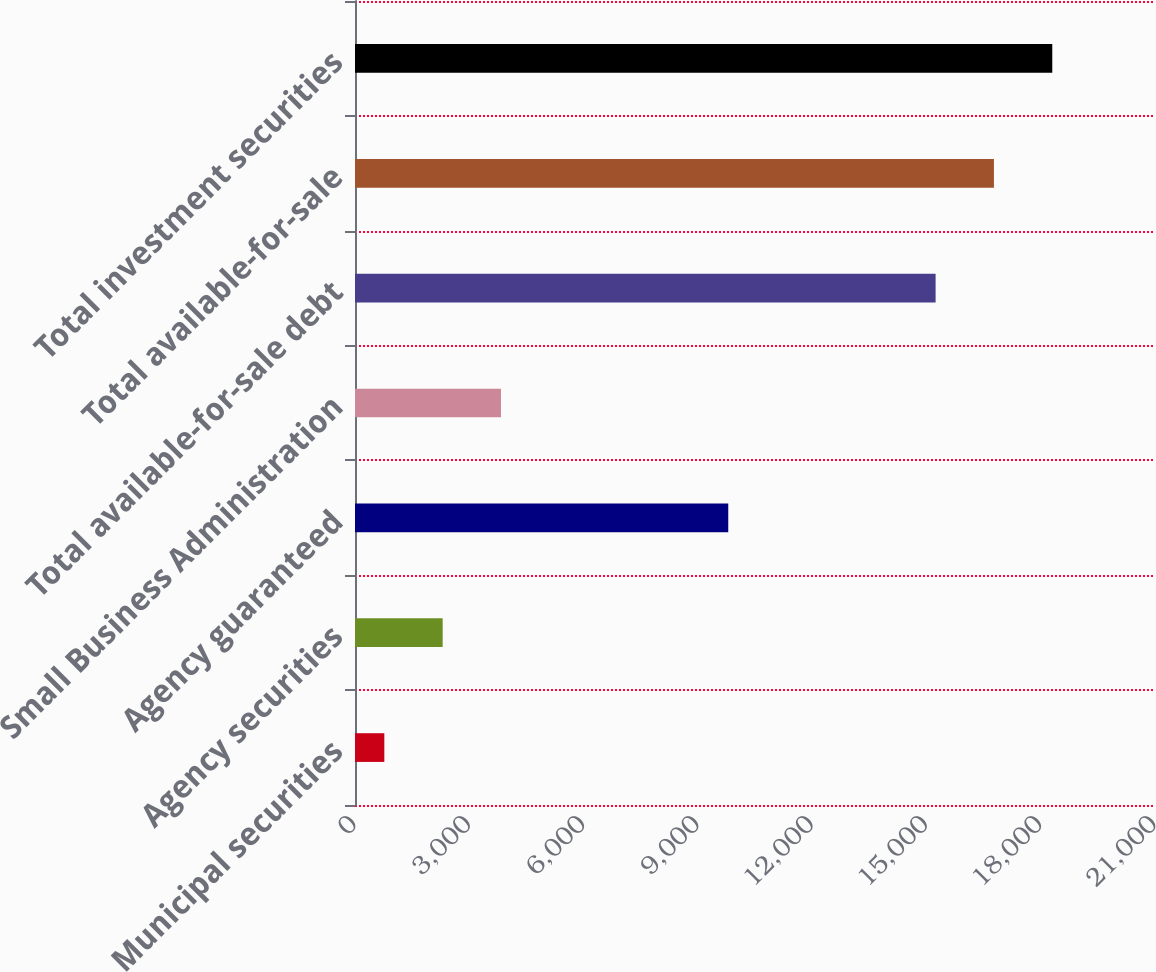Convert chart to OTSL. <chart><loc_0><loc_0><loc_500><loc_500><bar_chart><fcel>Municipal securities<fcel>Agency securities<fcel>Agency guaranteed<fcel>Small Business Administration<fcel>Total available-for-sale debt<fcel>Total available-for-sale<fcel>Total investment securities<nl><fcel>770<fcel>2301.3<fcel>9798<fcel>3832.6<fcel>15241<fcel>16772.3<fcel>18303.6<nl></chart> 